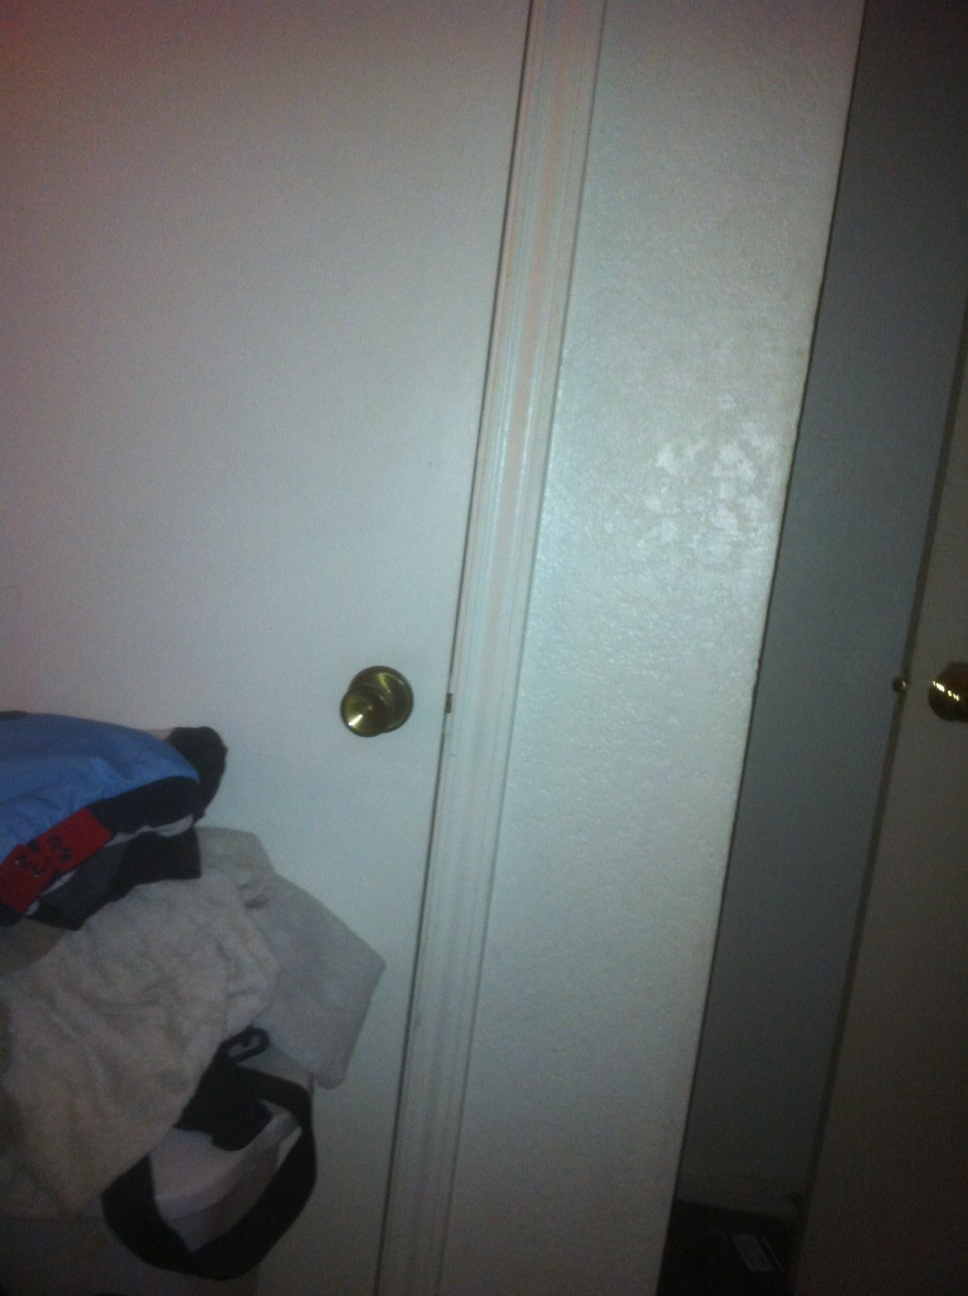What is in this picture? from Vizwiz The image shows a white door partially opened with a gold doorknob. The floor is carpeted and slightly dark, while the scene is lit with moderate lighting. In front of the door, there are items strewn about -- specifically some clothes and a small black bag. 